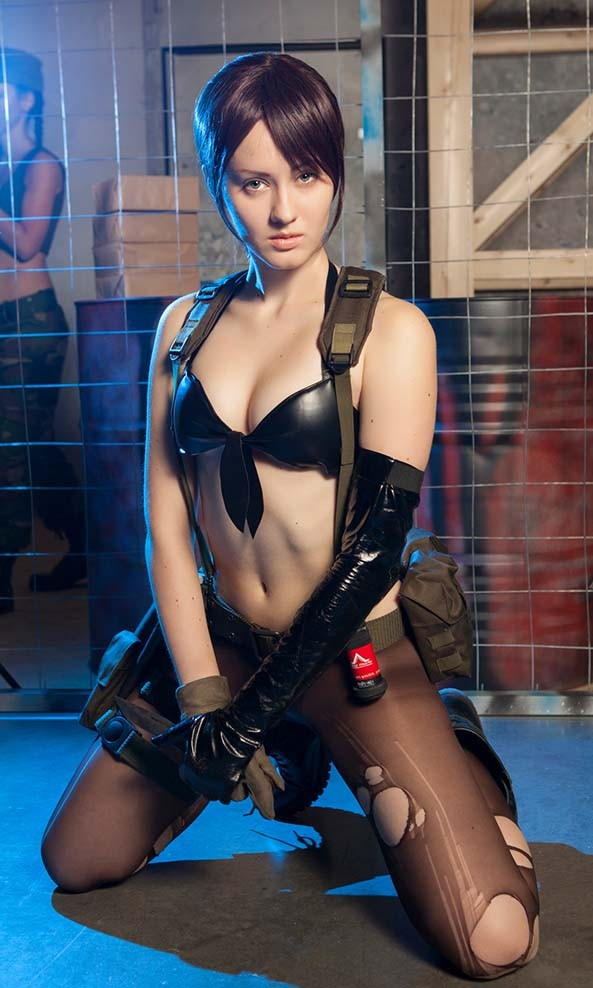What is the significance of the red emblem on the glove, and how might it relate to the character's identity or backstory? The red emblem on the glove is not only visually distinct but also tells us about the character's persona. While it does mirror the appearance of an 'A' and could easily be associated with themes of strength and leadership, without specific context it's hard to pinpoint its meaning definitively. If this character is part of a group of elite fighters or a particular faction in their universe, the emblem likely designates this affiliation and suggests a level of distinction or authority. Considering its prominent positioning, it is apparent that this emblem is a core part of the character's identity, and may symbolize their ethos or a crucial element of their personal narrative. Detailing elements like these helps fans in cosplay communities connect with the character and enrich their portrayal. 